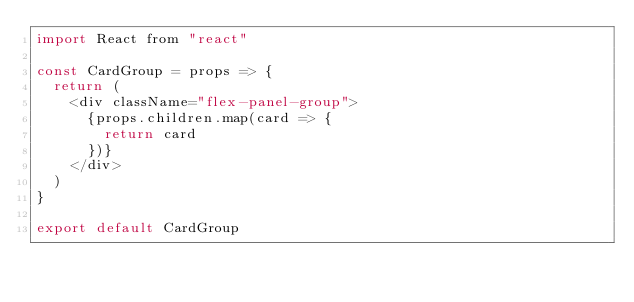<code> <loc_0><loc_0><loc_500><loc_500><_JavaScript_>import React from "react"

const CardGroup = props => {
  return (
    <div className="flex-panel-group">
      {props.children.map(card => {
        return card
      })}
    </div>
  )
}

export default CardGroup
</code> 